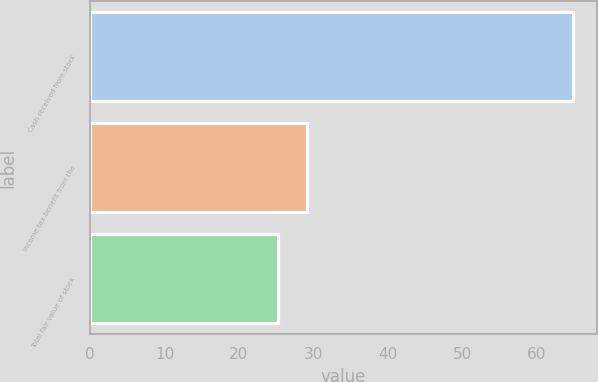Convert chart to OTSL. <chart><loc_0><loc_0><loc_500><loc_500><bar_chart><fcel>Cash received from stock<fcel>Income tax benefit from the<fcel>Total fair value of stock<nl><fcel>64.9<fcel>29.17<fcel>25.2<nl></chart> 